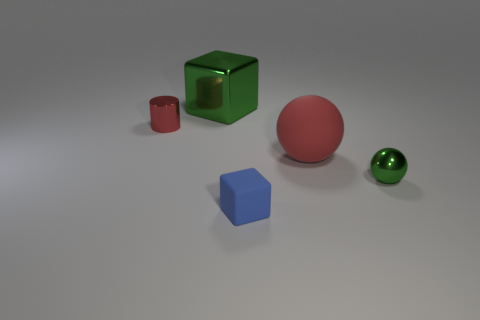Add 3 large brown objects. How many objects exist? 8 Subtract all cylinders. How many objects are left? 4 Subtract all shiny balls. Subtract all blocks. How many objects are left? 2 Add 4 green metal cubes. How many green metal cubes are left? 5 Add 5 large green metal blocks. How many large green metal blocks exist? 6 Subtract 0 purple spheres. How many objects are left? 5 